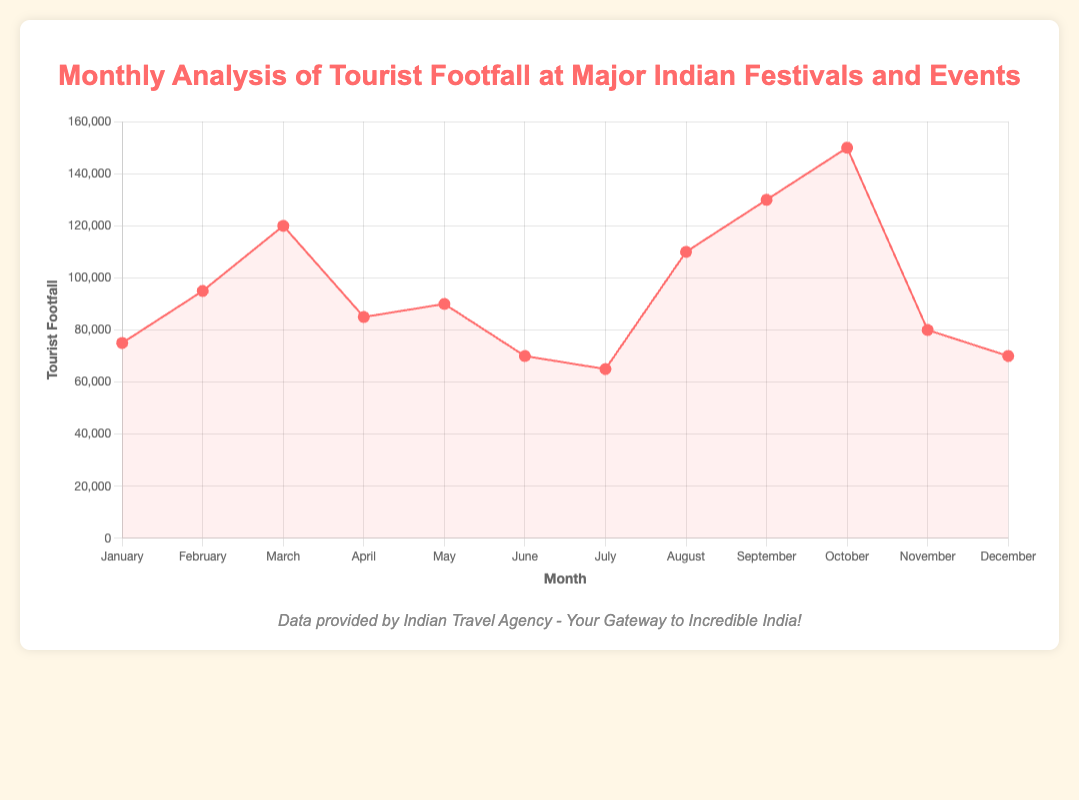Which month had the highest tourist footfall? By looking at the peak of the line chart, we see that October has the highest tourist footfall of 150,000 tourists for Durga Puja.
Answer: October Which month had the lowest tourist footfall? By looking at the lowest point of the line chart, July has the lowest tourist footfall of 65,000 tourists for the Hemis Festival.
Answer: July What is the difference in tourist footfall between the highest and lowest months? The highest tourist footfall is in October (150,000), and the lowest is in July (65,000). The difference is 150,000 - 65,000 = 85,000.
Answer: 85,000 How does the tourist footfall for Baisakhi in April compare to that for Janmashtami in August? Baisakhi in April had 85,000 tourists while Janmashtami in August had 110,000 tourists. Therefore, the footfall for Janmashtami is higher.
Answer: Janmashtami is higher by 25,000 What is the average tourist footfall from January to March? Adding the tourist footfall for January (75,000), February (95,000), and March (120,000) gives 75,000 + 95,000 + 120,000 = 290,000. The average is 290,000 / 3 = 96,667 tourists.
Answer: 96,667 Which months had tourist footfall between 70,000 and 90,000? From the chart, the months with tourist footfall between 70,000 and 90,000 are January (75,000), April (85,000), May (90,000), June (70,000), and November (80,000).
Answer: January, April, May, June, November How many months recorded a tourist footfall greater than 100,000? By observing the chart, the months with tourist footfall greater than 100,000 are March (120,000), August (110,000), September (130,000), and October (150,000). This is a total of 4 months.
Answer: 4 months What is the total tourist footfall from May to August? Adding the tourist footfall for May (90,000), June (70,000), July (65,000), and August (110,000) gives 90,000 + 70,000 + 65,000 + 110,000 = 335,000 tourists.
Answer: 335,000 Which month's event contributes to the second-lowest tourist footfall? The second-lowest tourist footfall is in December with 70,000 tourists for the Hornbill Festival.
Answer: December What visually indicates the months with the highest and lowest tourist footfall? The highest tourist footfall occurs in October, indicated by the peak of the line chart. The lowest occurs in July, indicated by the lowest point of the line chart.
Answer: October (highest), July (lowest) 